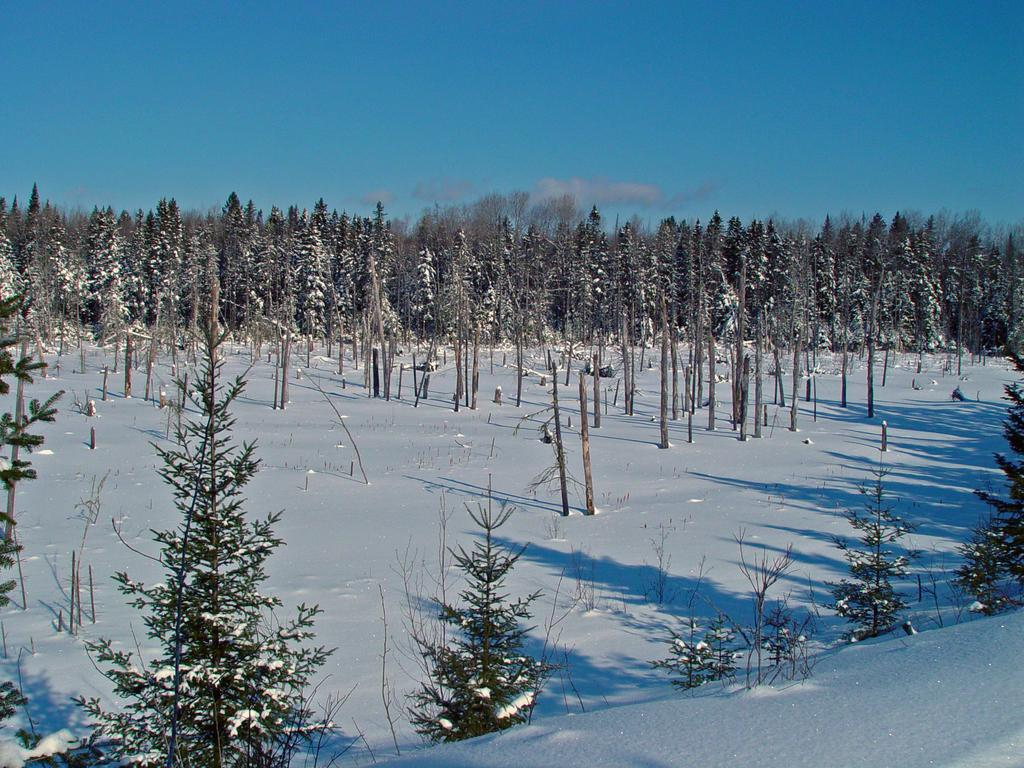What is the condition of the ground in the image? The ground in the image is covered in snow. What type of vegetation is present in the image? There are many trees in the image. How do the trees appear in the image? The trees are full of snow. What is the color of the sky in the image? The sky in the image is clear and blue. Can you see any insects crawling on the trees in the image? There are no insects visible in the image; the trees are covered in snow. How many eyes can be seen on the trees in the image? Trees do not have eyes, so this question cannot be answered based on the image. 